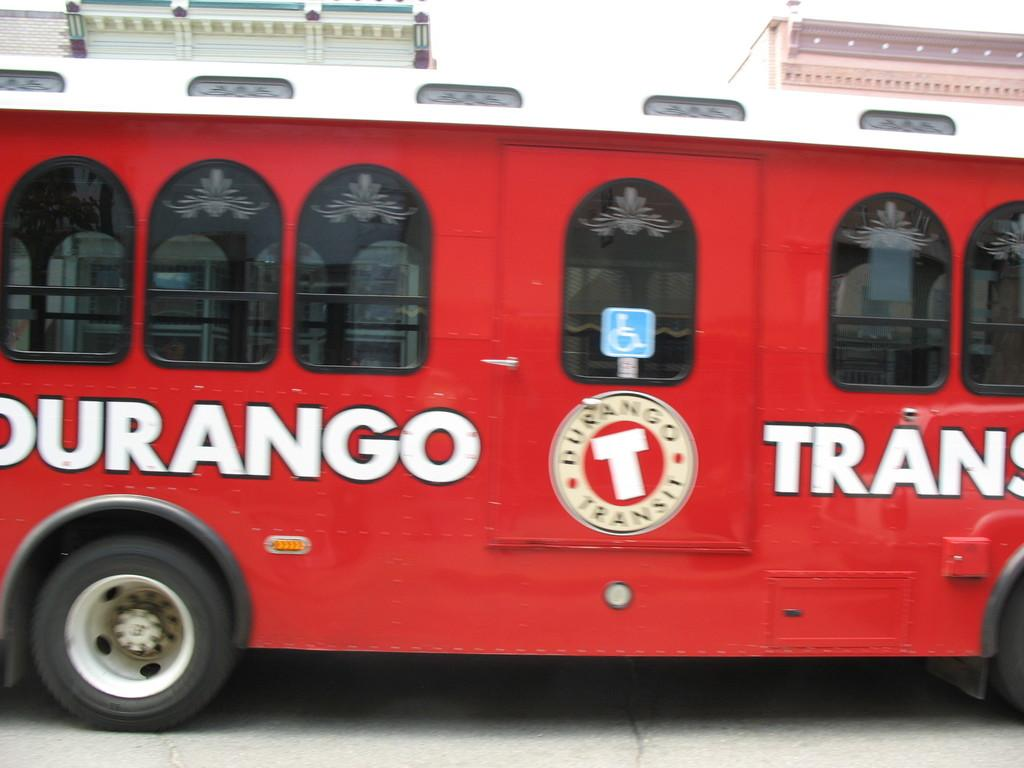What is the main subject in the center of the image? There is a bus in the center of the image. What can be seen in the background of the image? There are buildings and the sky visible in the background of the image. How many stems are attached to the bus in the image? There are no stems present in the image; the bus is a vehicle and does not have stems. 